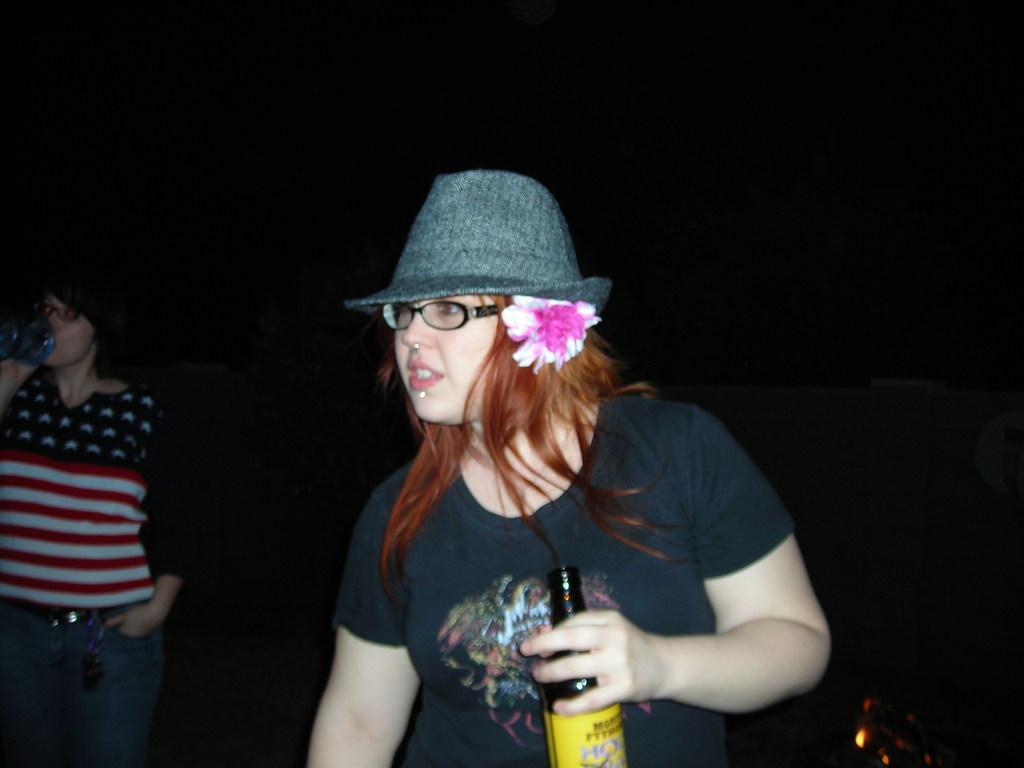Describe this image in one or two sentences. In this picture we can see a woman standing and holding a bottle with her hand. she wear a cap. She has spectacles. And there is a flower. Even we can see one more person on the left side of the picture. 